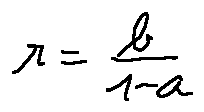Convert formula to latex. <formula><loc_0><loc_0><loc_500><loc_500>r = \frac { b } { 1 - a }</formula> 